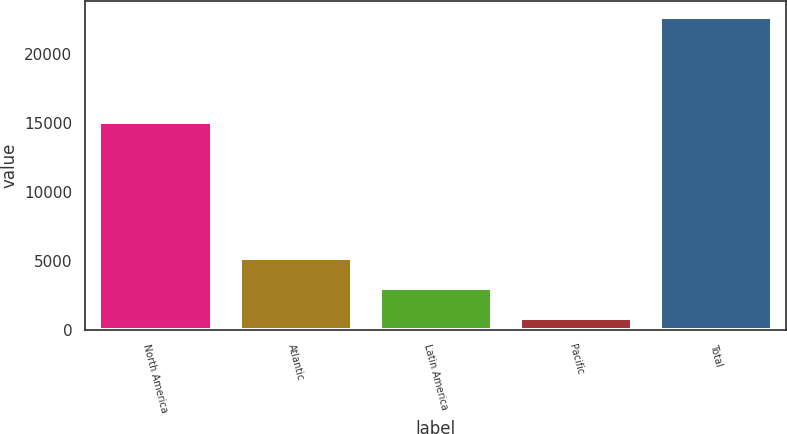Convert chart to OTSL. <chart><loc_0><loc_0><loc_500><loc_500><bar_chart><fcel>North America<fcel>Atlantic<fcel>Latin America<fcel>Pacific<fcel>Total<nl><fcel>15065<fcel>5233<fcel>3050<fcel>867<fcel>22697<nl></chart> 